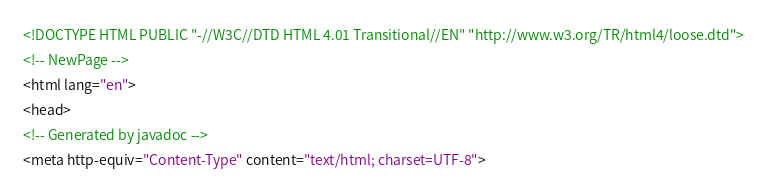Convert code to text. <code><loc_0><loc_0><loc_500><loc_500><_HTML_><!DOCTYPE HTML PUBLIC "-//W3C//DTD HTML 4.01 Transitional//EN" "http://www.w3.org/TR/html4/loose.dtd">
<!-- NewPage -->
<html lang="en">
<head>
<!-- Generated by javadoc -->
<meta http-equiv="Content-Type" content="text/html; charset=UTF-8"></code> 